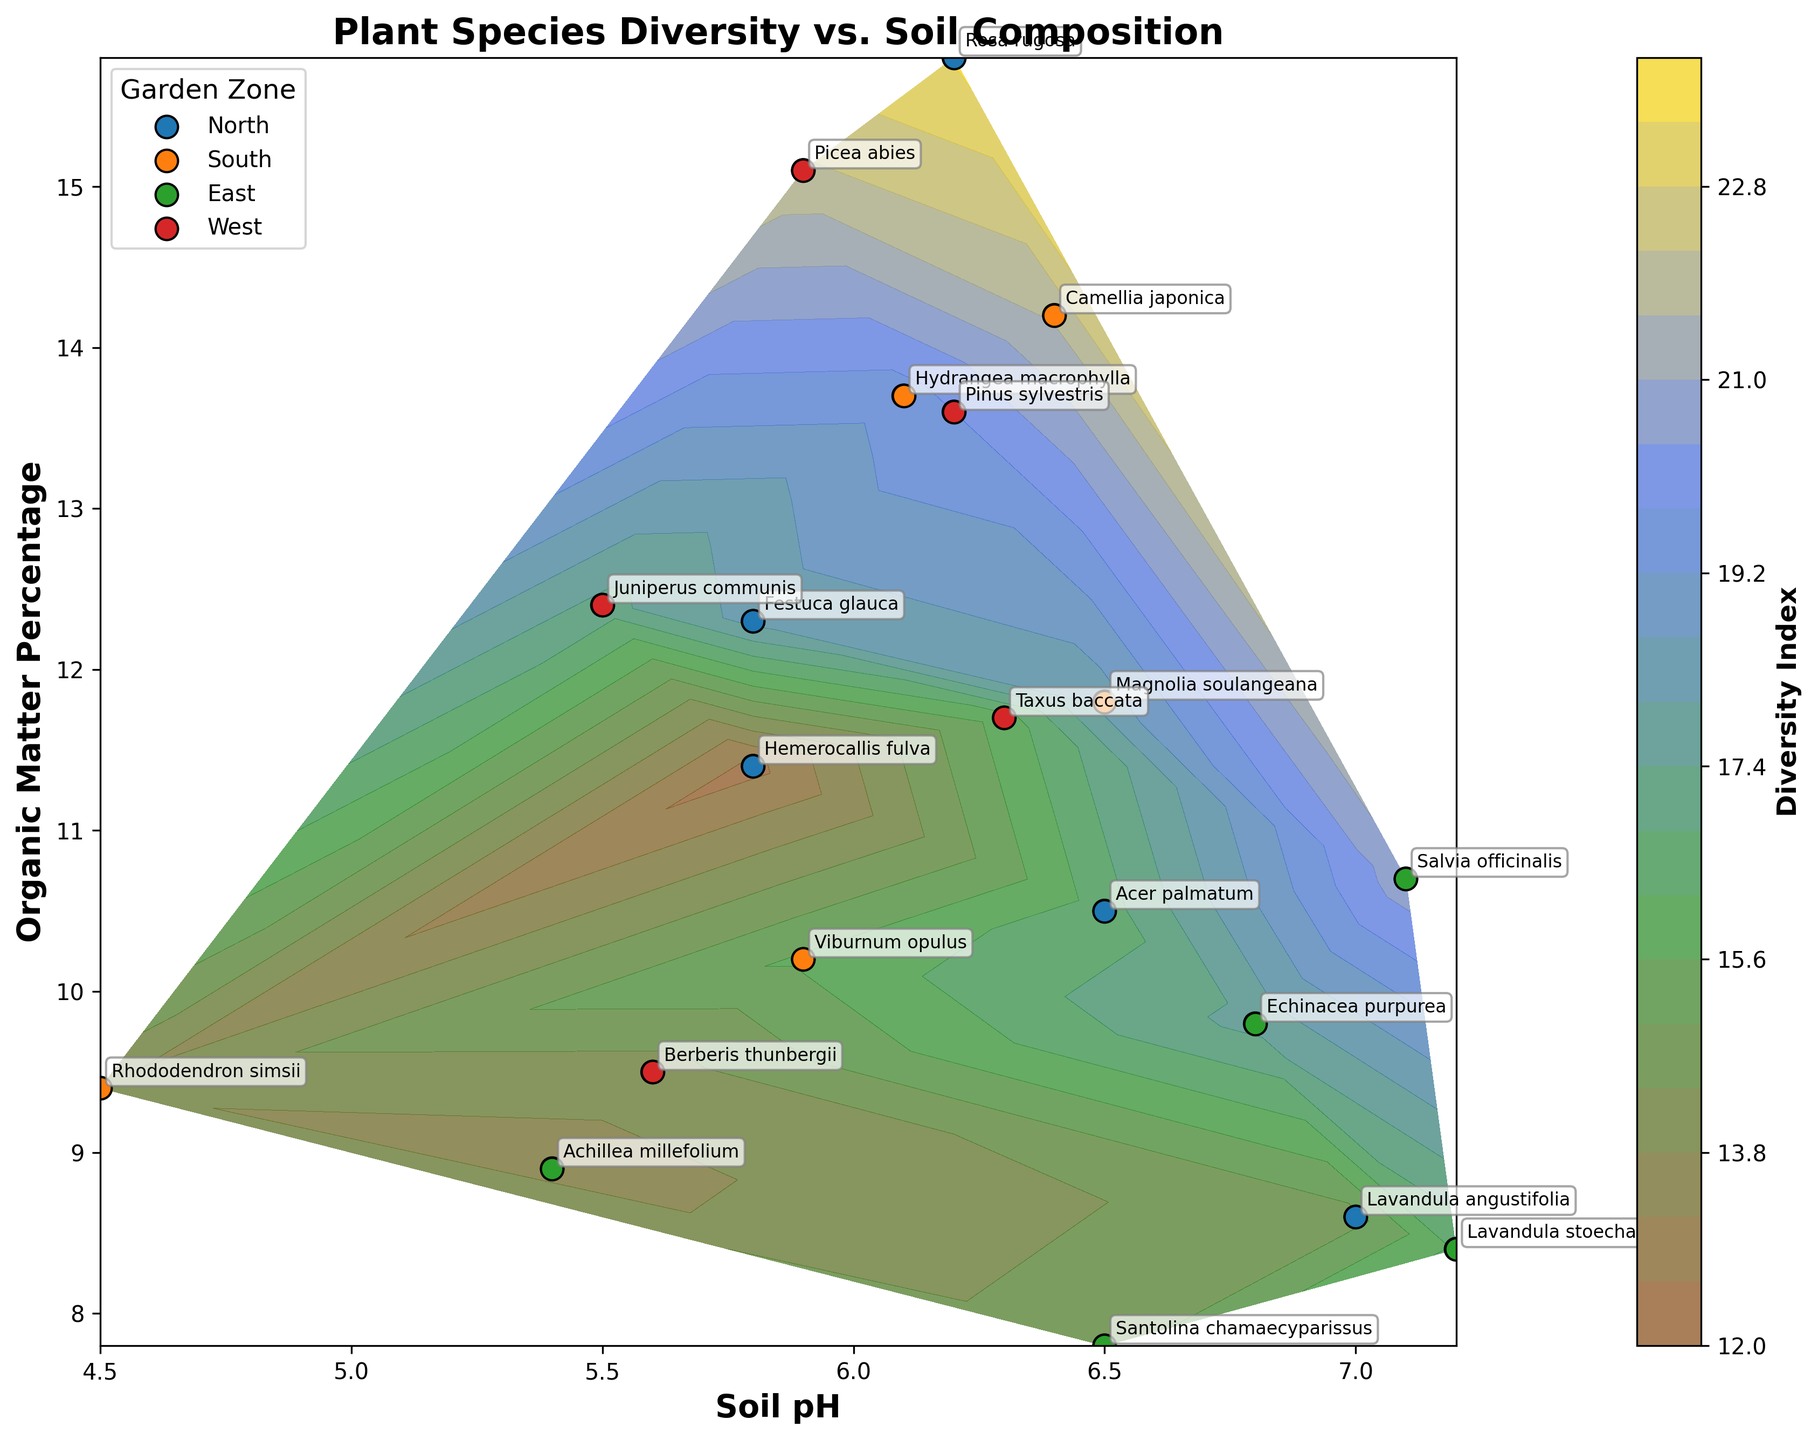What's the title of the figure? The title of the figure is typically displayed at the top of the plot. Here, the title reads "Plant Species Diversity vs. Soil Composition".
Answer: Plant Species Diversity vs. Soil Composition What does the x-axis represent? The x-axis usually has a label indicating what it represents. In this plot, it is labeled "Soil pH", which means it represents the pH level of the soil.
Answer: Soil pH Which garden zone has the largest diversity index at a lower soil pH? To answer this question, look at the points with smaller soil pH values and note their Diversity Index and zones. "Rhododendron simsii" in the South Zone has the highest Diversity Index of 13.9 at a soil pH of 4.5.
Answer: South Which plant species is annotated at the highest organic matter percentage? The annotations on the figure indicate the plant species. Check the y-axis for the highest organic matter percentage and refer to the annotation. "Rosa rugosa" in the North Zone is annotated at the highest organic matter percentage of 15.8%.
Answer: Rosa rugosa How many data points are plotted in total? Count each individual point representing plant species in the plot. There are 20 data points represented in the plot.
Answer: 20 Which garden zone has the most uniform soil pH values? Evaluate each garden zone by checking the spread of the soil pH values for the points corresponding to each zone. The North Zone appears to have soil pH values roughly between 5.8 and 7.0, indicating a more uniform distribution compared to the other zones.
Answer: North Is there any correlation visible between soil pH and organic matter percentage? Check the overall trend of points as soil pH changes. Across different zones, there doesn't appear to be a strong linear or obvious correlation between soil pH and organic matter percentage visually.
Answer: No In which zone can the highest diversity index be found, and what is its value? Check the colors representing the Diversity Index and their corresponding zones. The highest diversity index of 23.5 is found in the North Zone, represented by "Rosa rugosa".
Answer: North, 23.5 Compare the diversity indices of "Lavandula angustifolia" and "Santolina chamaecyparissus". Which one is higher? Locate the annotations for both plant species and compare their Diversity Index values. "Lavandula angustifolia" has a Diversity Index of 14.8, whereas "Santolina chamaecyparissus" has a Diversity Index of 14.7. Therefore, "Lavandula angustifolia" is slightly higher.
Answer: Lavandula angustifolia 